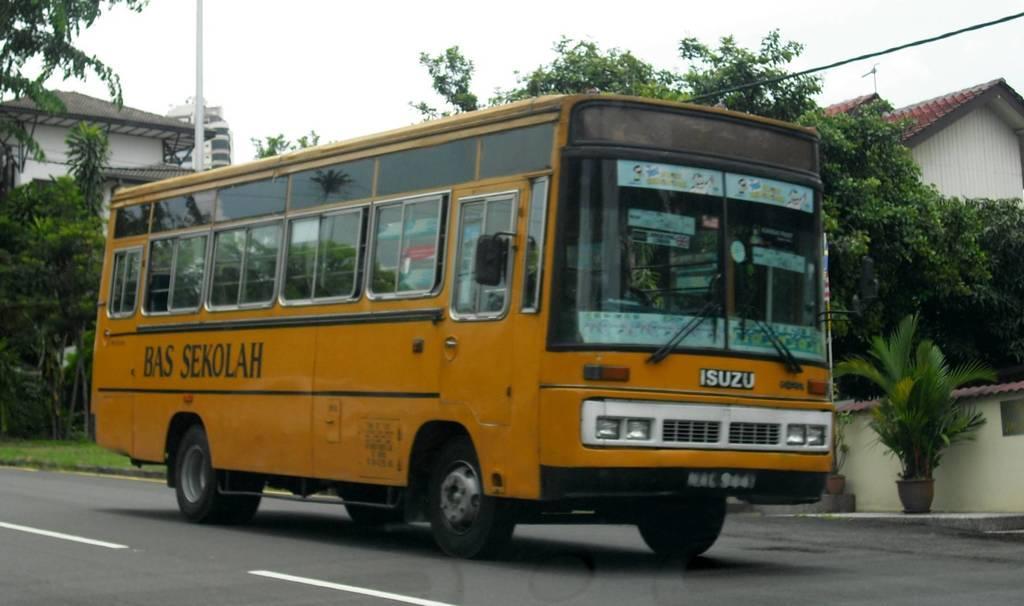Can you describe this image briefly? In this picture we can see vehicle, plants, trees, buildings, pole and sky. Vehicle is on the road. 